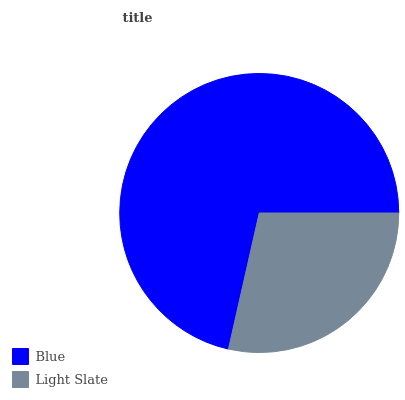Is Light Slate the minimum?
Answer yes or no. Yes. Is Blue the maximum?
Answer yes or no. Yes. Is Light Slate the maximum?
Answer yes or no. No. Is Blue greater than Light Slate?
Answer yes or no. Yes. Is Light Slate less than Blue?
Answer yes or no. Yes. Is Light Slate greater than Blue?
Answer yes or no. No. Is Blue less than Light Slate?
Answer yes or no. No. Is Blue the high median?
Answer yes or no. Yes. Is Light Slate the low median?
Answer yes or no. Yes. Is Light Slate the high median?
Answer yes or no. No. Is Blue the low median?
Answer yes or no. No. 